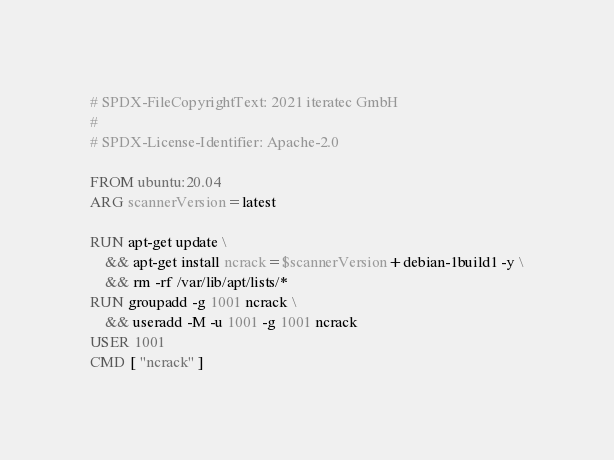Convert code to text. <code><loc_0><loc_0><loc_500><loc_500><_Dockerfile_># SPDX-FileCopyrightText: 2021 iteratec GmbH
#
# SPDX-License-Identifier: Apache-2.0

FROM ubuntu:20.04
ARG scannerVersion=latest

RUN apt-get update \
    && apt-get install ncrack=$scannerVersion+debian-1build1 -y \
    && rm -rf /var/lib/apt/lists/*
RUN groupadd -g 1001 ncrack \
    && useradd -M -u 1001 -g 1001 ncrack
USER 1001
CMD [ "ncrack" ]

</code> 